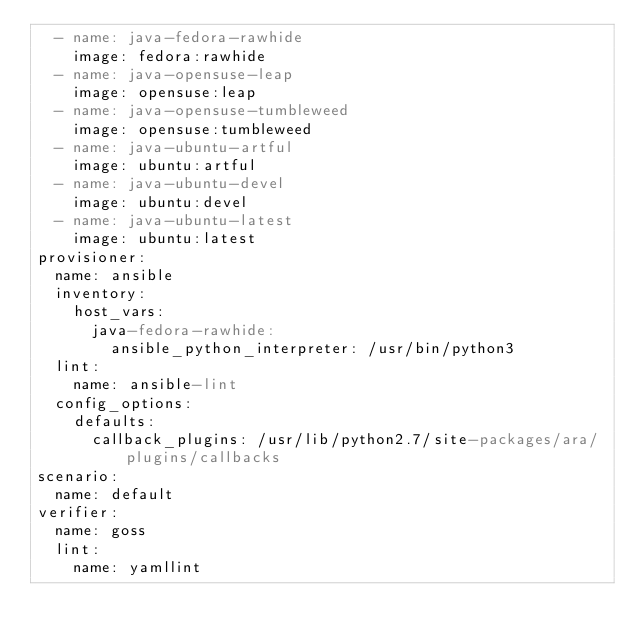Convert code to text. <code><loc_0><loc_0><loc_500><loc_500><_YAML_>  - name: java-fedora-rawhide
    image: fedora:rawhide
  - name: java-opensuse-leap
    image: opensuse:leap
  - name: java-opensuse-tumbleweed
    image: opensuse:tumbleweed
  - name: java-ubuntu-artful
    image: ubuntu:artful
  - name: java-ubuntu-devel
    image: ubuntu:devel
  - name: java-ubuntu-latest
    image: ubuntu:latest
provisioner:
  name: ansible
  inventory:
    host_vars:
      java-fedora-rawhide:
        ansible_python_interpreter: /usr/bin/python3
  lint:
    name: ansible-lint
  config_options:
    defaults:
      callback_plugins: /usr/lib/python2.7/site-packages/ara/plugins/callbacks
scenario:
  name: default
verifier:
  name: goss
  lint:
    name: yamllint
</code> 